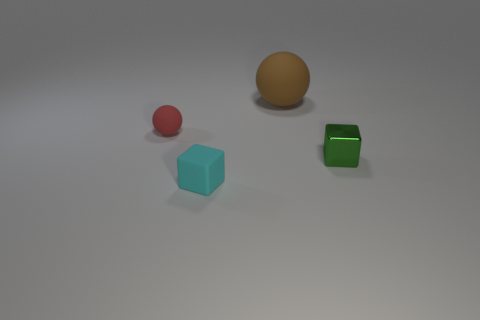Add 1 tiny spheres. How many objects exist? 5 Add 4 small cyan blocks. How many small cyan blocks are left? 5 Add 1 green objects. How many green objects exist? 2 Subtract 0 green spheres. How many objects are left? 4 Subtract all small cubes. Subtract all tiny red rubber things. How many objects are left? 1 